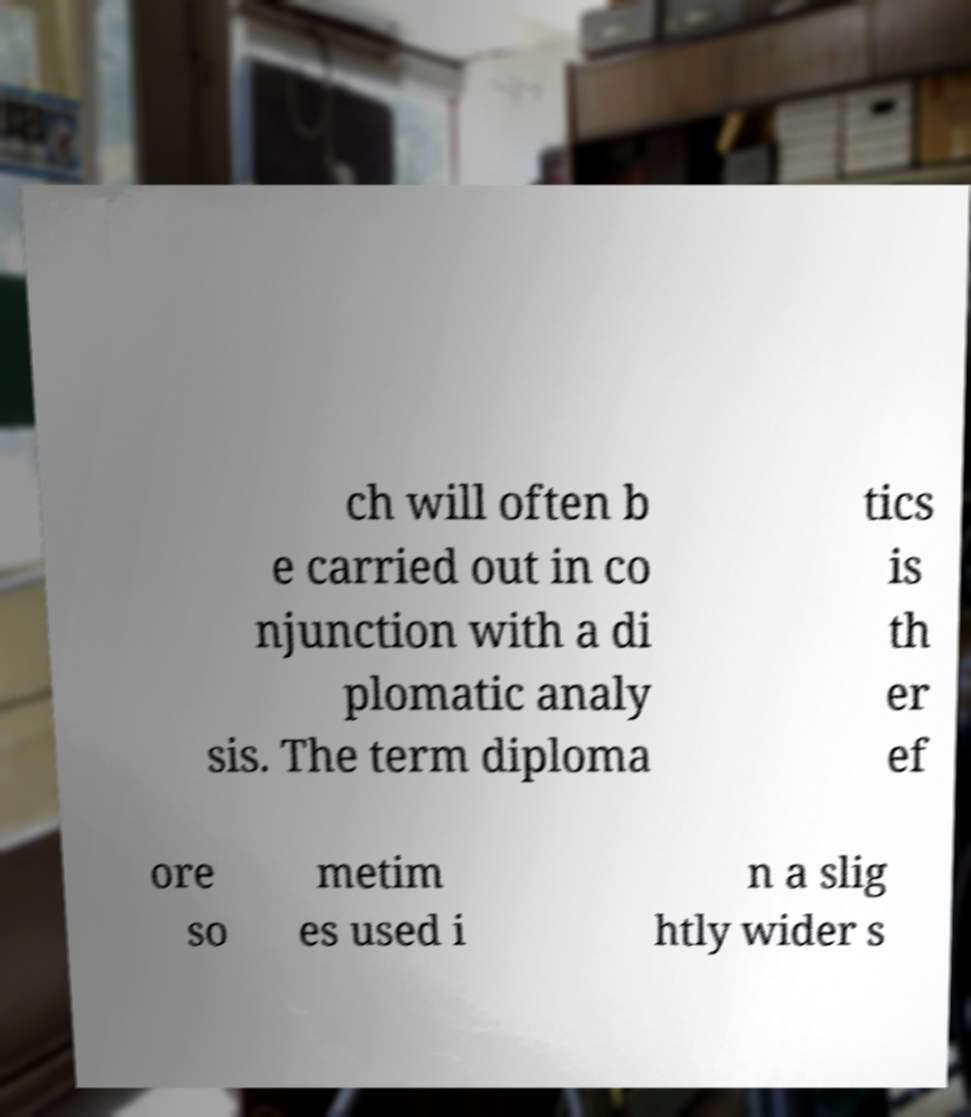Could you extract and type out the text from this image? ch will often b e carried out in co njunction with a di plomatic analy sis. The term diploma tics is th er ef ore so metim es used i n a slig htly wider s 